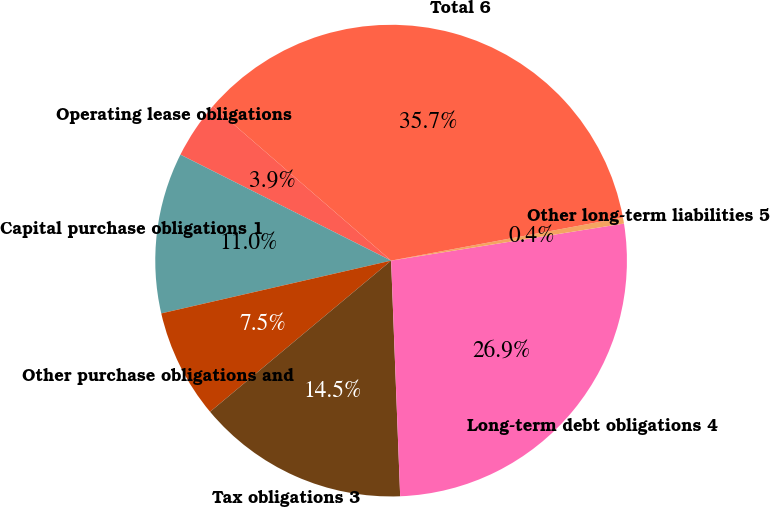Convert chart to OTSL. <chart><loc_0><loc_0><loc_500><loc_500><pie_chart><fcel>Operating lease obligations<fcel>Capital purchase obligations 1<fcel>Other purchase obligations and<fcel>Tax obligations 3<fcel>Long-term debt obligations 4<fcel>Other long-term liabilities 5<fcel>Total 6<nl><fcel>3.94%<fcel>11.01%<fcel>7.48%<fcel>14.54%<fcel>26.9%<fcel>0.41%<fcel>35.72%<nl></chart> 